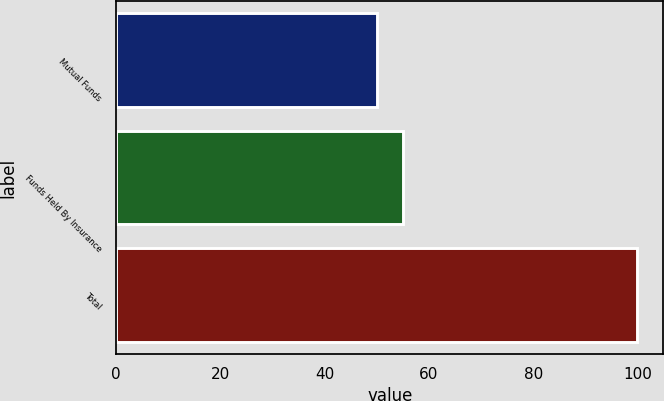Convert chart. <chart><loc_0><loc_0><loc_500><loc_500><bar_chart><fcel>Mutual Funds<fcel>Funds Held By Insurance<fcel>Total<nl><fcel>50<fcel>55<fcel>100<nl></chart> 